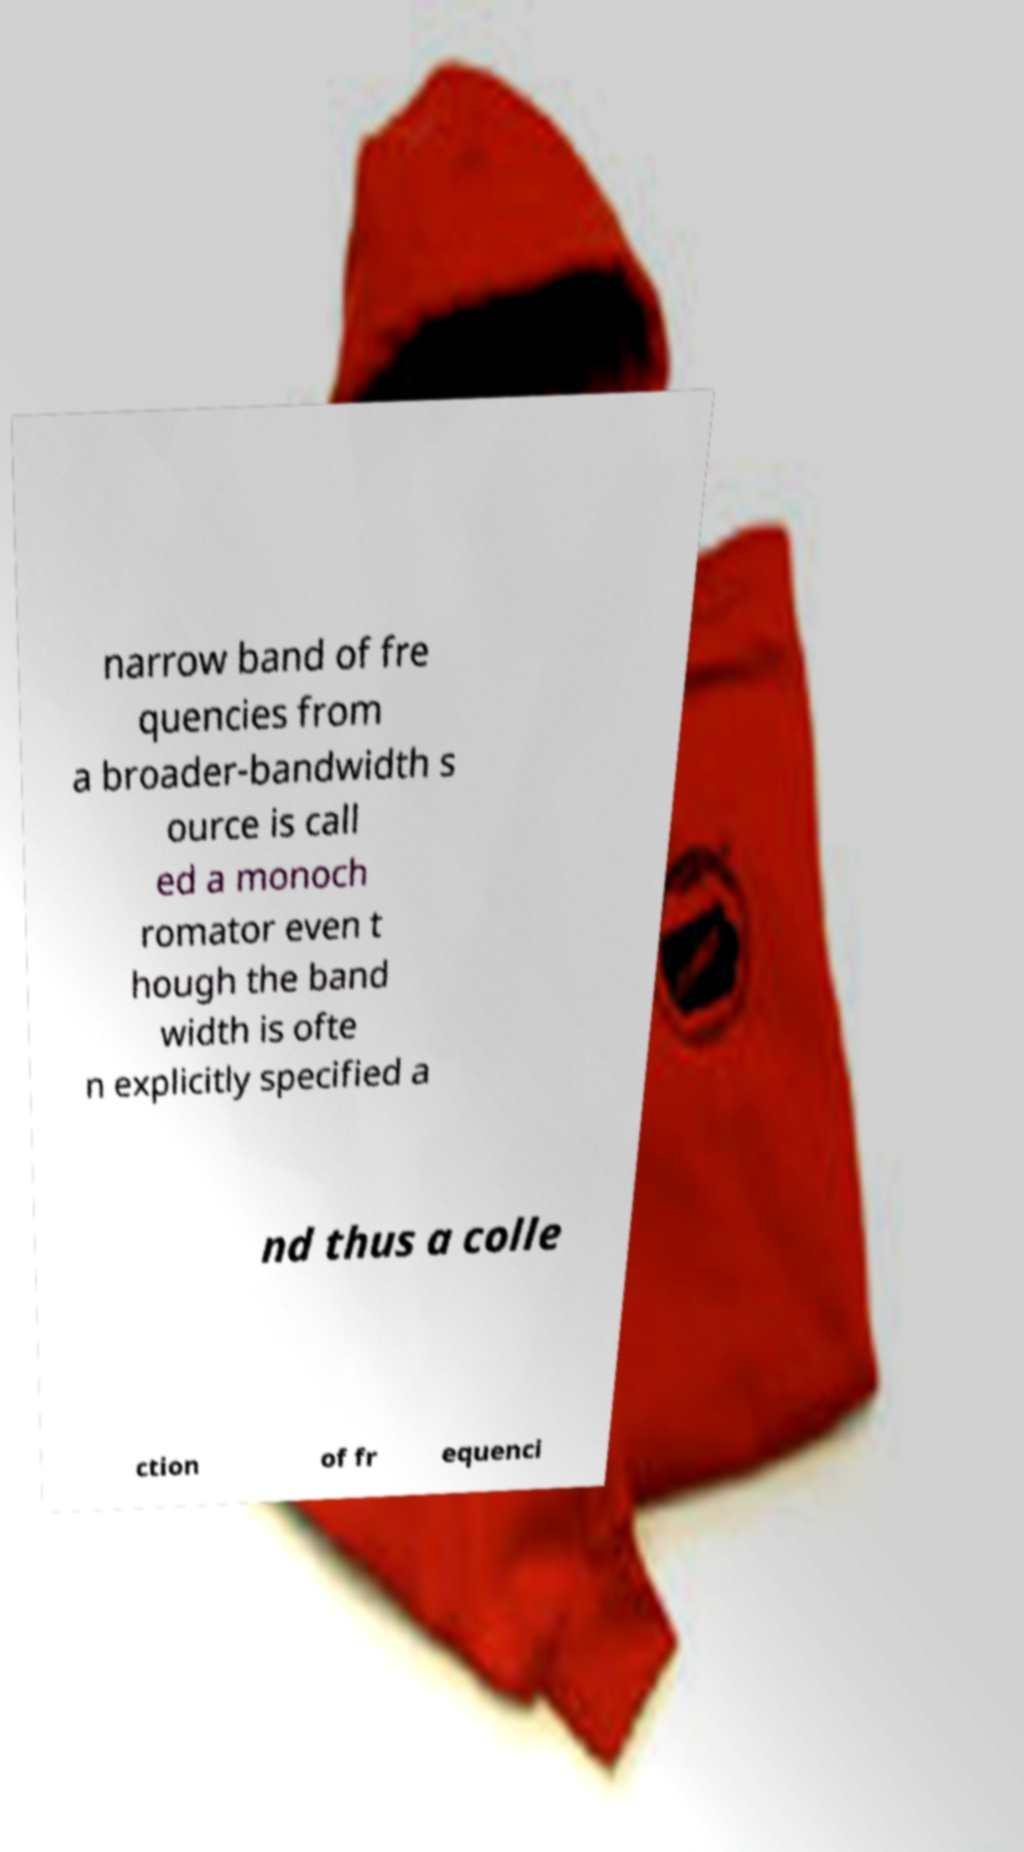Can you read and provide the text displayed in the image?This photo seems to have some interesting text. Can you extract and type it out for me? narrow band of fre quencies from a broader-bandwidth s ource is call ed a monoch romator even t hough the band width is ofte n explicitly specified a nd thus a colle ction of fr equenci 